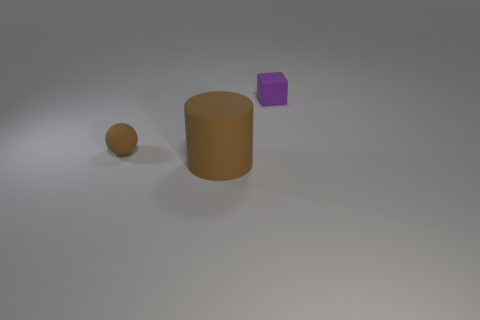Add 3 small purple matte cubes. How many objects exist? 6 Subtract all cubes. How many objects are left? 2 Subtract all tiny purple rubber objects. Subtract all tiny green matte cubes. How many objects are left? 2 Add 2 rubber cylinders. How many rubber cylinders are left? 3 Add 2 big brown shiny balls. How many big brown shiny balls exist? 2 Subtract 0 yellow blocks. How many objects are left? 3 